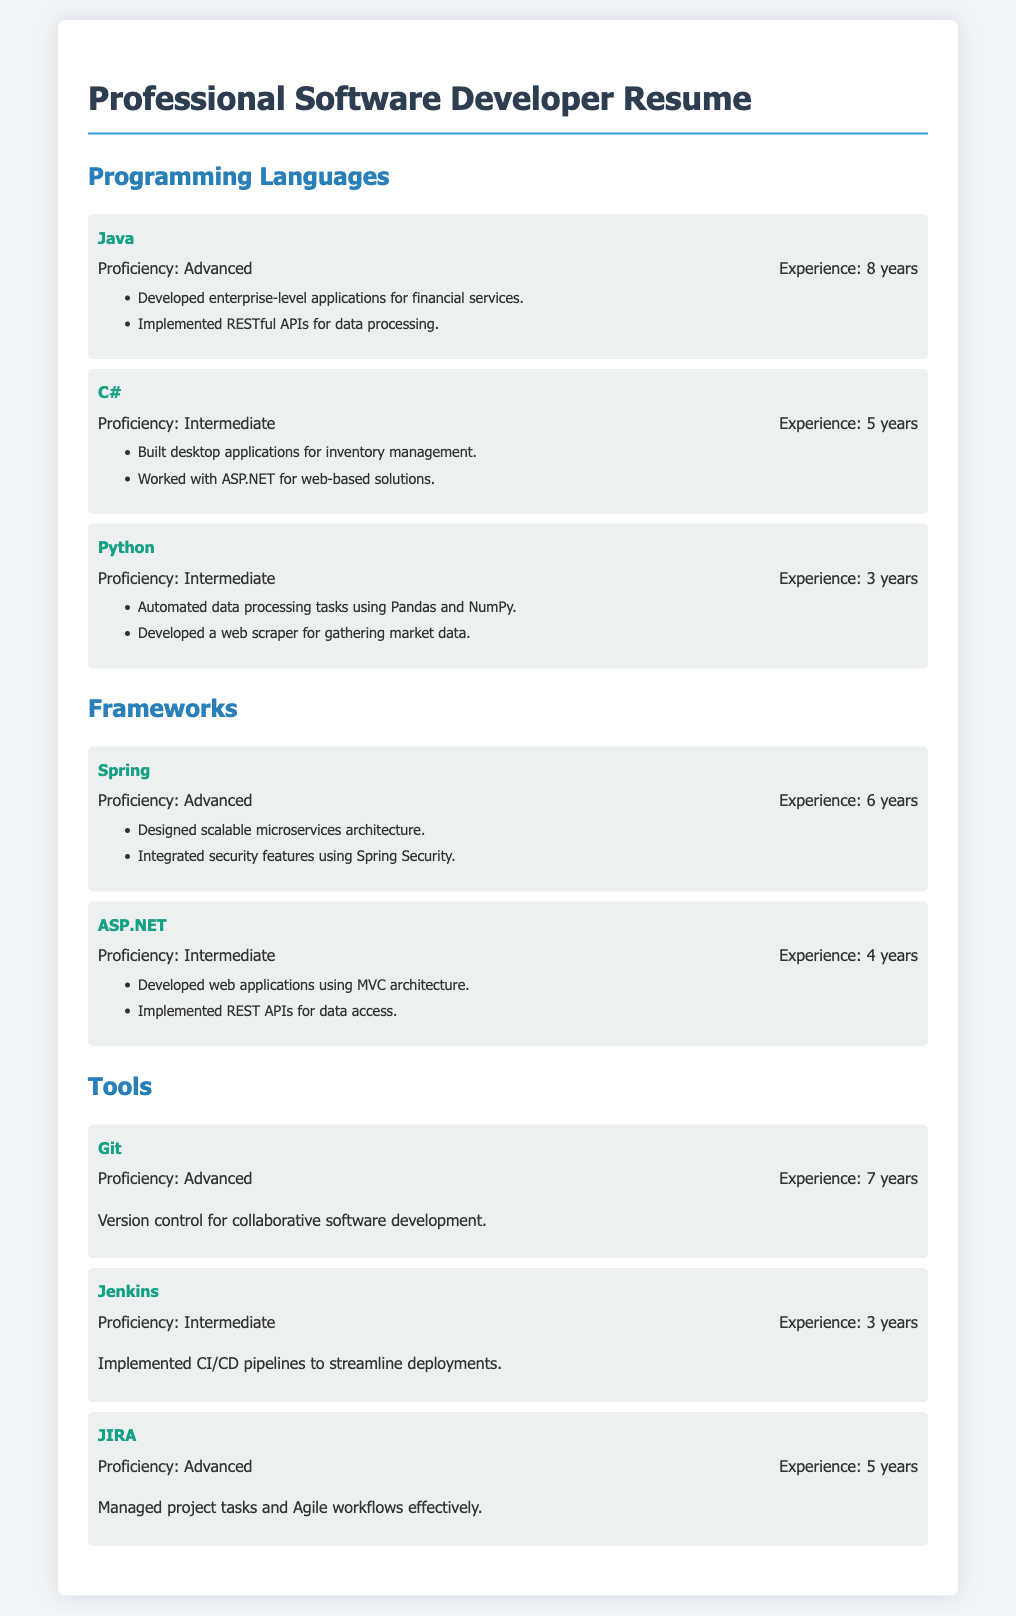What is the programming language with advanced proficiency? The document lists Java as a programming language with advanced proficiency.
Answer: Java How many years of experience does the candidate have in C#? The document states that the candidate has 5 years of experience in C#.
Answer: 5 years Which framework is used for scalable microservices architecture? The document indicates that Spring is the framework used for scalable microservices architecture.
Answer: Spring What is the proficiency level of Git? Git has an advanced proficiency level as mentioned in the document.
Answer: Advanced How many years of experience does the candidate have with Jenkins? The candidate has 3 years of experience with Jenkins.
Answer: 3 years What type of applications were developed using ASP.NET? The document specifies that web applications were developed using ASP.NET.
Answer: Web applications What tool is used for managing project tasks and Agile workflows? The document mentions JIRA as the tool used for managing project tasks and Agile workflows.
Answer: JIRA Which programming language does the candidate have intermediate proficiency in? The document lists Python as a programming language with intermediate proficiency.
Answer: Python What security features were integrated using the Spring framework? The document mentions that security features were integrated using Spring Security.
Answer: Spring Security 